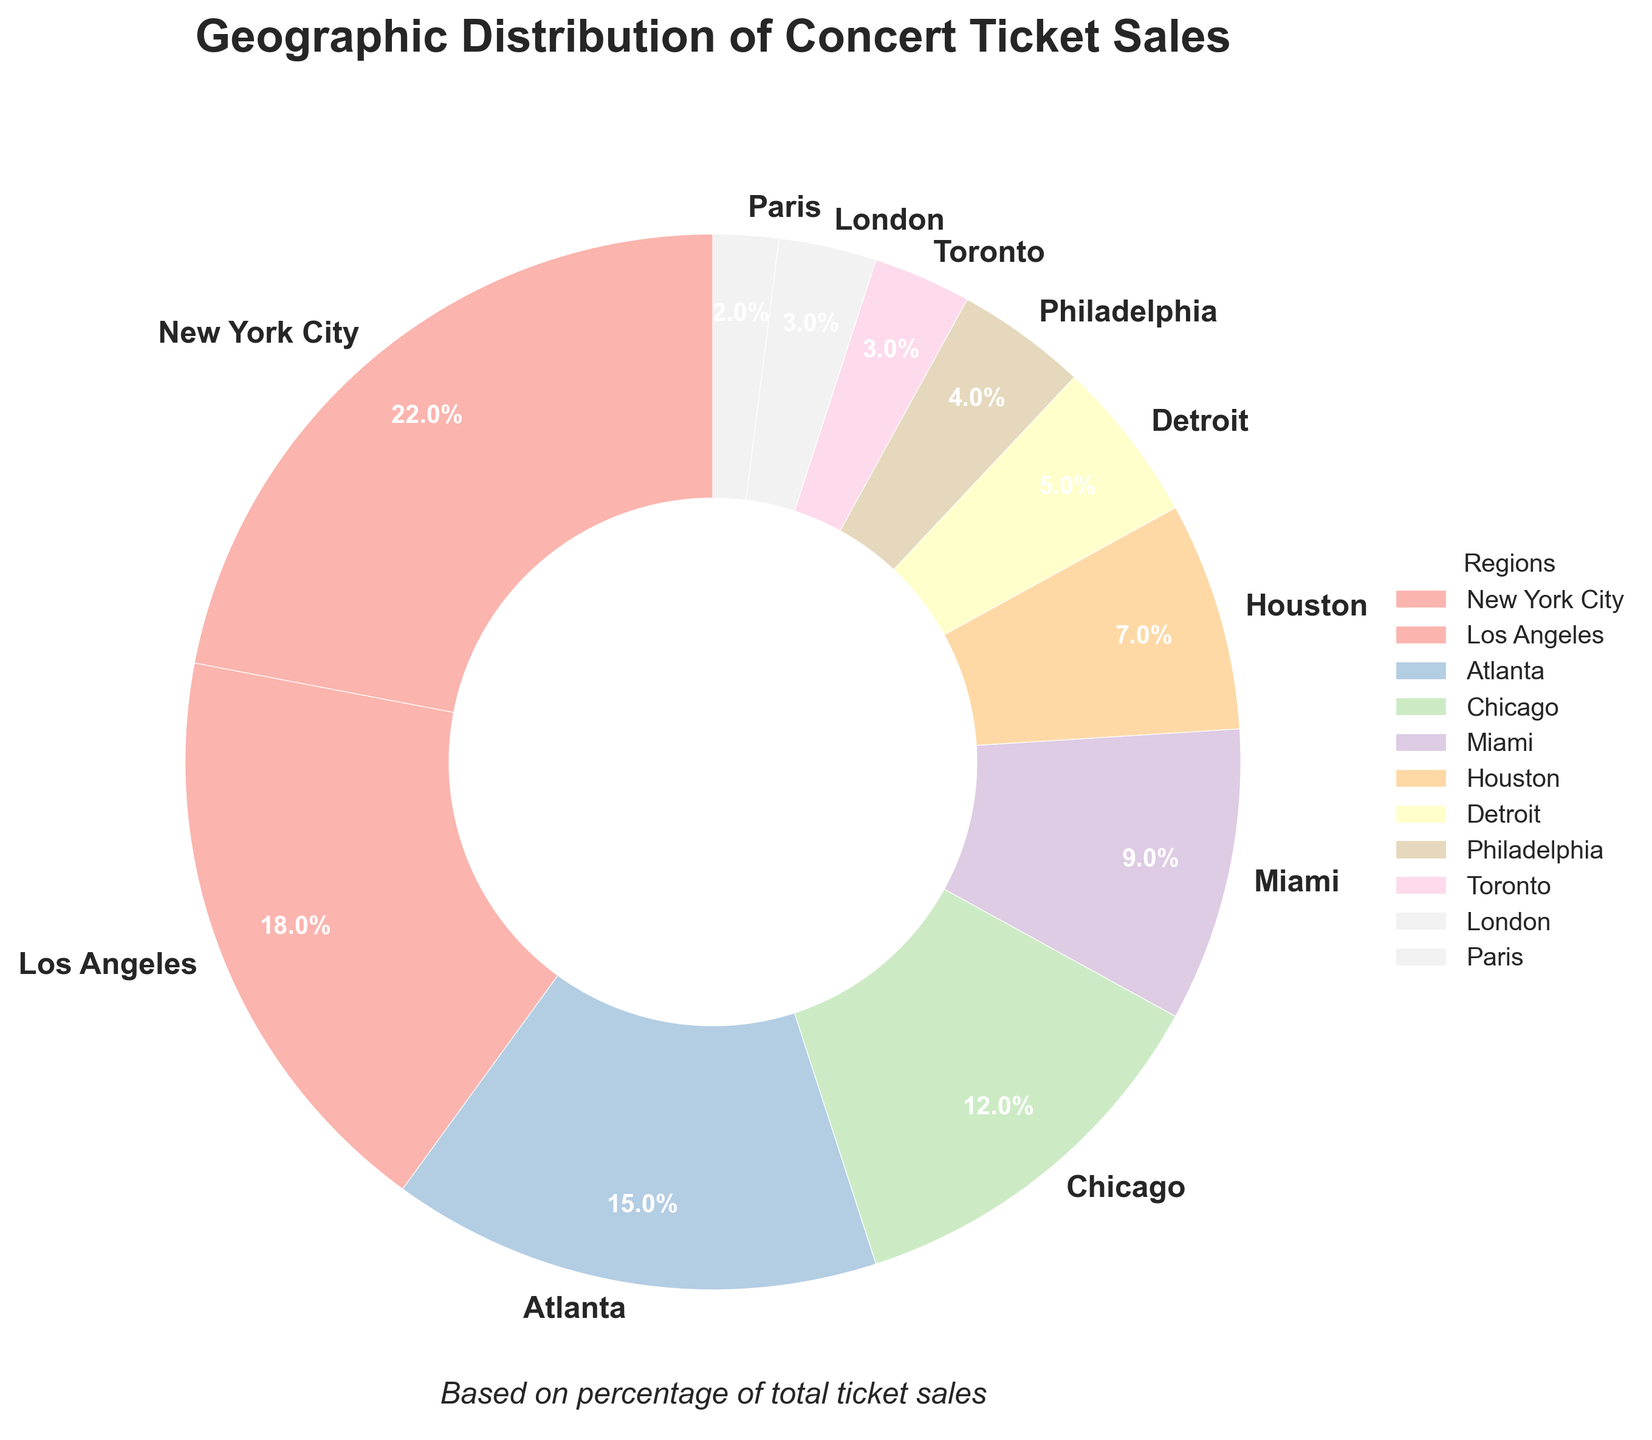What's the percentage of total ticket sales for New York City and Los Angeles combined? To find the combined percentage, add the percentages for New York City and Los Angeles: 22% + 18% = 40%.
Answer: 40% Which region has the lowest percentage of ticket sales? By examining the pie chart, Paris has the lowest percentage at 2%.
Answer: Paris Are the combined ticket sales for Miami and Houston higher than those for Atlanta? Add the percentages for Miami and Houston: 9% + 7% = 16%. Compare it to Atlanta's 15%. 16% is higher than 15%.
Answer: Yes Which region sells more tickets: Detroit or Philadelphia? Compare the percentages for Detroit (5%) and Philadelphia (4%). 5% is greater than 4%.
Answer: Detroit What is the difference in ticket sales between Atlanta and Chicago? Subtract the percentage for Chicago from Atlanta: 15% - 12% = 3%.
Answer: 3% How many regions have a ticket sales percentage greater than 10%? By visually scanning the chart, the regions above 10% are New York City, Los Angeles, Atlanta, and Chicago. There are 4 regions.
Answer: 4 Is the ticket sales percentage for Toronto equal to that for London? Compare the percentages for Toronto and London. Both have 3%.
Answer: Yes Which region has around half the percentage of ticket sales of New York City? Look for a region with roughly half of New York City's 22%. Miami has around 9%, which is close to half.
Answer: Miami What is the sum of the smallest three regions' percentages? Sum the percentages for the three smallest regions: Toronto (3%), London (3%), and Paris (2%). 3% + 3% + 2% = 8%.
Answer: 8% How does the percentage of ticket sales for Los Angeles compare to that for Houston? Compare the percentages for Los Angeles (18%) and Houston (7%). 18% is more than double 7%.
Answer: Los Angeles is more than twice that of Houston 